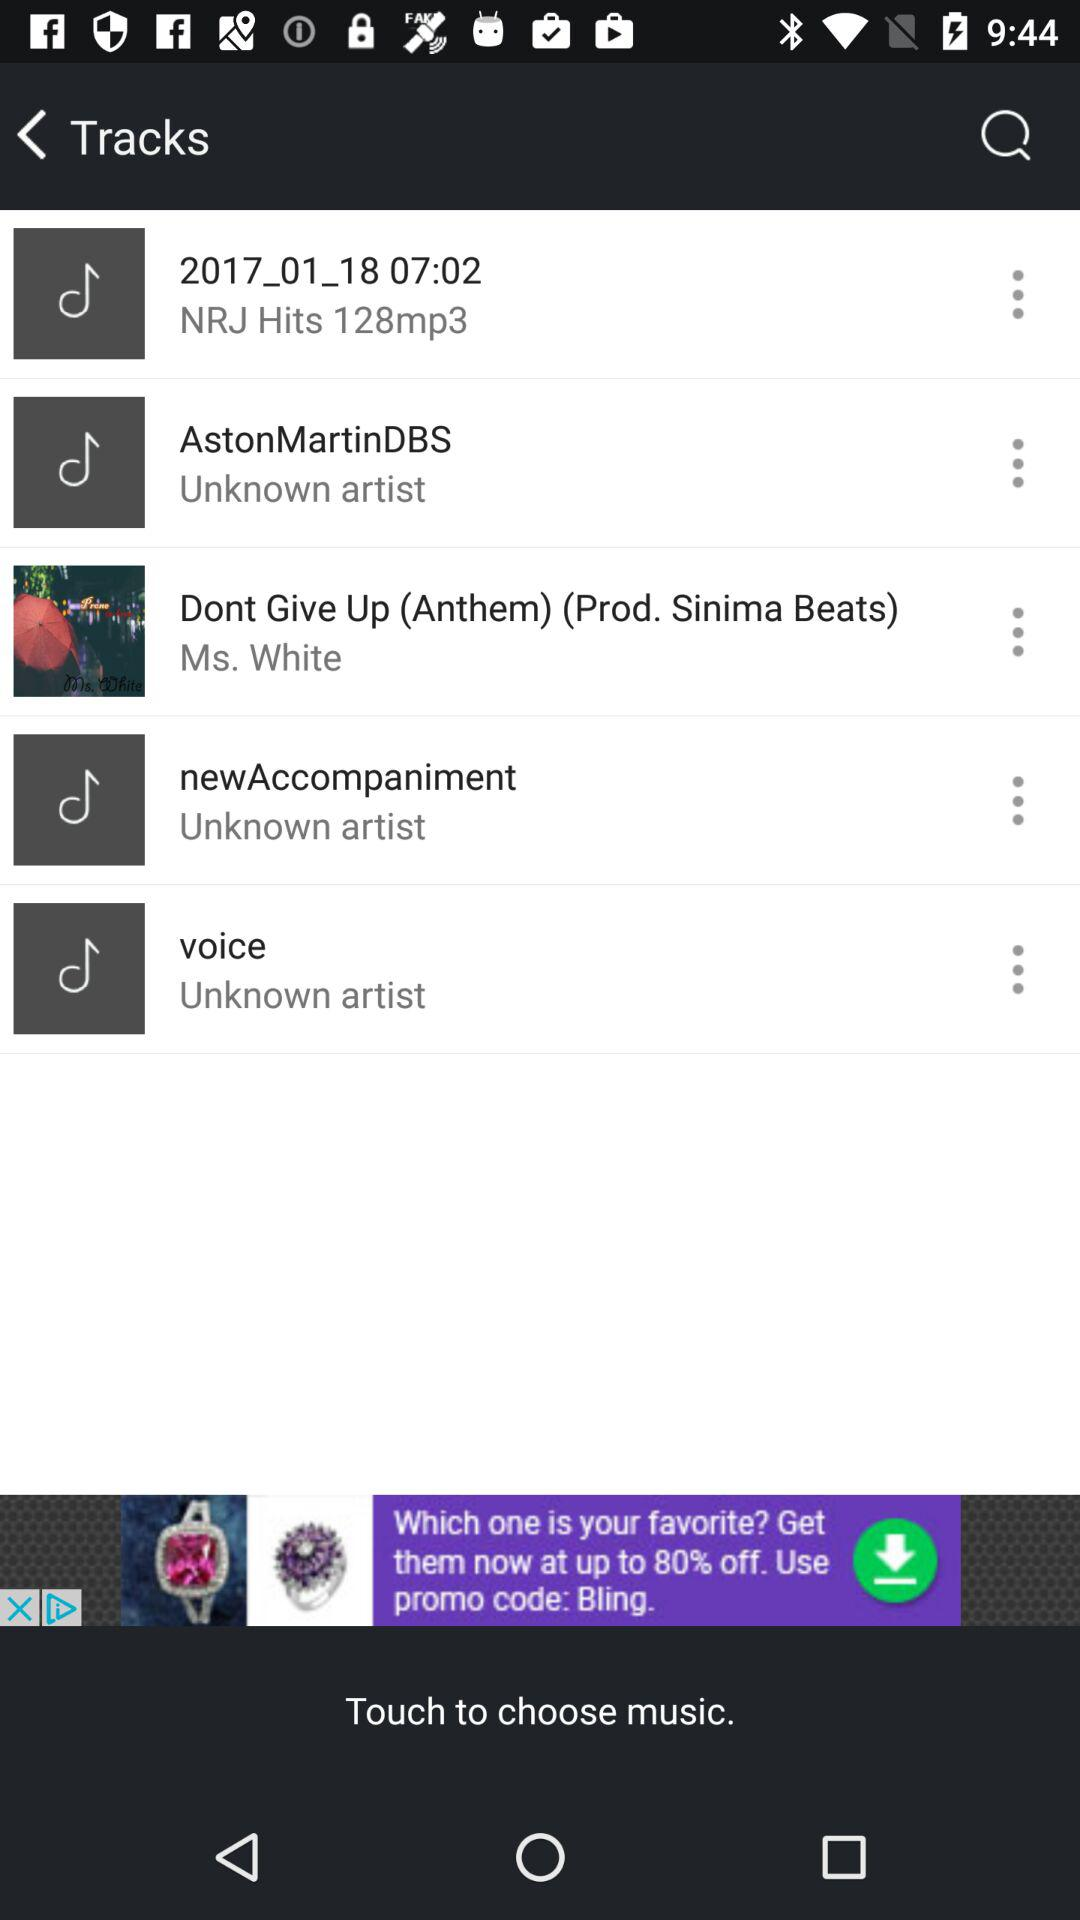Who is the artist of "Dont Give Up"? The artist of "Dont Give Up" is "Ms. White". 